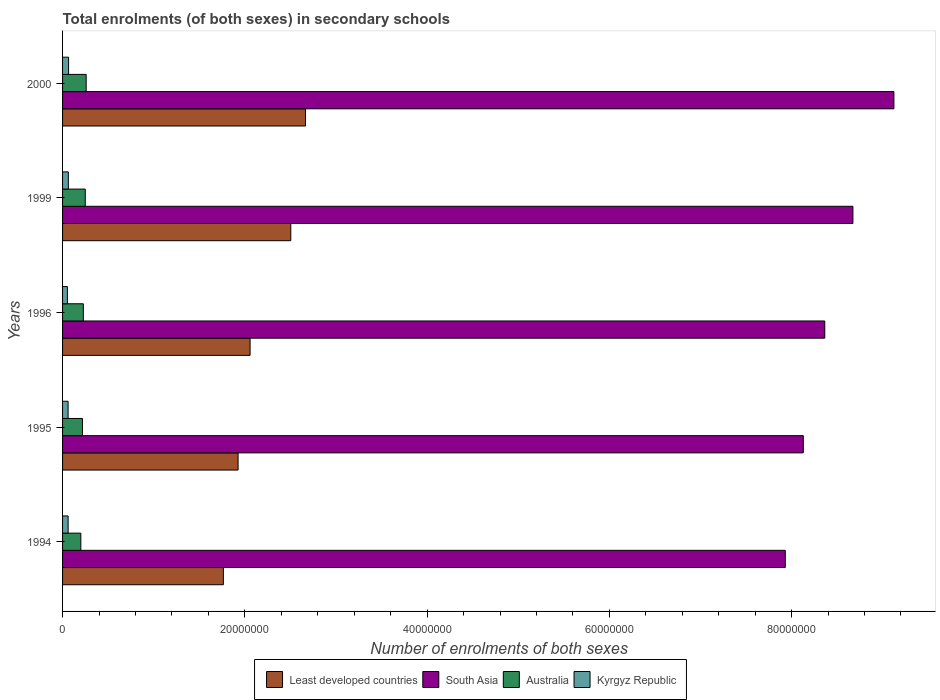How many different coloured bars are there?
Provide a succinct answer. 4. How many groups of bars are there?
Your response must be concise. 5. Are the number of bars per tick equal to the number of legend labels?
Your response must be concise. Yes. What is the number of enrolments in secondary schools in South Asia in 1999?
Your response must be concise. 8.67e+07. Across all years, what is the maximum number of enrolments in secondary schools in Least developed countries?
Offer a very short reply. 2.67e+07. Across all years, what is the minimum number of enrolments in secondary schools in Australia?
Offer a very short reply. 2.00e+06. In which year was the number of enrolments in secondary schools in South Asia maximum?
Make the answer very short. 2000. In which year was the number of enrolments in secondary schools in Kyrgyz Republic minimum?
Give a very brief answer. 1996. What is the total number of enrolments in secondary schools in Least developed countries in the graph?
Your answer should be very brief. 1.09e+08. What is the difference between the number of enrolments in secondary schools in Least developed countries in 1995 and that in 1999?
Keep it short and to the point. -5.78e+06. What is the difference between the number of enrolments in secondary schools in Australia in 1996 and the number of enrolments in secondary schools in Least developed countries in 1999?
Keep it short and to the point. -2.28e+07. What is the average number of enrolments in secondary schools in Least developed countries per year?
Provide a short and direct response. 2.18e+07. In the year 1995, what is the difference between the number of enrolments in secondary schools in Kyrgyz Republic and number of enrolments in secondary schools in South Asia?
Keep it short and to the point. -8.07e+07. What is the ratio of the number of enrolments in secondary schools in Australia in 1994 to that in 1999?
Ensure brevity in your answer.  0.8. Is the difference between the number of enrolments in secondary schools in Kyrgyz Republic in 1996 and 1999 greater than the difference between the number of enrolments in secondary schools in South Asia in 1996 and 1999?
Give a very brief answer. Yes. What is the difference between the highest and the second highest number of enrolments in secondary schools in Kyrgyz Republic?
Give a very brief answer. 2.61e+04. What is the difference between the highest and the lowest number of enrolments in secondary schools in Australia?
Your answer should be compact. 5.86e+05. What does the 1st bar from the top in 2000 represents?
Give a very brief answer. Kyrgyz Republic. What does the 4th bar from the bottom in 1999 represents?
Your answer should be very brief. Kyrgyz Republic. How many bars are there?
Your response must be concise. 20. How many years are there in the graph?
Your response must be concise. 5. Are the values on the major ticks of X-axis written in scientific E-notation?
Offer a terse response. No. Where does the legend appear in the graph?
Your answer should be compact. Bottom center. How many legend labels are there?
Make the answer very short. 4. How are the legend labels stacked?
Make the answer very short. Horizontal. What is the title of the graph?
Provide a succinct answer. Total enrolments (of both sexes) in secondary schools. What is the label or title of the X-axis?
Give a very brief answer. Number of enrolments of both sexes. What is the label or title of the Y-axis?
Your answer should be very brief. Years. What is the Number of enrolments of both sexes in Least developed countries in 1994?
Offer a terse response. 1.76e+07. What is the Number of enrolments of both sexes of South Asia in 1994?
Keep it short and to the point. 7.93e+07. What is the Number of enrolments of both sexes of Australia in 1994?
Provide a short and direct response. 2.00e+06. What is the Number of enrolments of both sexes in Kyrgyz Republic in 1994?
Your response must be concise. 6.10e+05. What is the Number of enrolments of both sexes of Least developed countries in 1995?
Make the answer very short. 1.93e+07. What is the Number of enrolments of both sexes of South Asia in 1995?
Offer a terse response. 8.13e+07. What is the Number of enrolments of both sexes of Australia in 1995?
Offer a very short reply. 2.18e+06. What is the Number of enrolments of both sexes in Kyrgyz Republic in 1995?
Keep it short and to the point. 6.06e+05. What is the Number of enrolments of both sexes in Least developed countries in 1996?
Your answer should be very brief. 2.06e+07. What is the Number of enrolments of both sexes in South Asia in 1996?
Ensure brevity in your answer.  8.36e+07. What is the Number of enrolments of both sexes of Australia in 1996?
Your answer should be compact. 2.28e+06. What is the Number of enrolments of both sexes of Kyrgyz Republic in 1996?
Give a very brief answer. 5.31e+05. What is the Number of enrolments of both sexes of Least developed countries in 1999?
Give a very brief answer. 2.50e+07. What is the Number of enrolments of both sexes of South Asia in 1999?
Ensure brevity in your answer.  8.67e+07. What is the Number of enrolments of both sexes in Australia in 1999?
Ensure brevity in your answer.  2.49e+06. What is the Number of enrolments of both sexes in Kyrgyz Republic in 1999?
Ensure brevity in your answer.  6.33e+05. What is the Number of enrolments of both sexes of Least developed countries in 2000?
Offer a very short reply. 2.67e+07. What is the Number of enrolments of both sexes of South Asia in 2000?
Your answer should be compact. 9.12e+07. What is the Number of enrolments of both sexes of Australia in 2000?
Offer a very short reply. 2.59e+06. What is the Number of enrolments of both sexes in Kyrgyz Republic in 2000?
Your response must be concise. 6.59e+05. Across all years, what is the maximum Number of enrolments of both sexes of Least developed countries?
Provide a short and direct response. 2.67e+07. Across all years, what is the maximum Number of enrolments of both sexes in South Asia?
Your response must be concise. 9.12e+07. Across all years, what is the maximum Number of enrolments of both sexes in Australia?
Make the answer very short. 2.59e+06. Across all years, what is the maximum Number of enrolments of both sexes of Kyrgyz Republic?
Give a very brief answer. 6.59e+05. Across all years, what is the minimum Number of enrolments of both sexes in Least developed countries?
Make the answer very short. 1.76e+07. Across all years, what is the minimum Number of enrolments of both sexes of South Asia?
Make the answer very short. 7.93e+07. Across all years, what is the minimum Number of enrolments of both sexes in Australia?
Offer a terse response. 2.00e+06. Across all years, what is the minimum Number of enrolments of both sexes of Kyrgyz Republic?
Your response must be concise. 5.31e+05. What is the total Number of enrolments of both sexes of Least developed countries in the graph?
Ensure brevity in your answer.  1.09e+08. What is the total Number of enrolments of both sexes of South Asia in the graph?
Keep it short and to the point. 4.22e+08. What is the total Number of enrolments of both sexes in Australia in the graph?
Give a very brief answer. 1.15e+07. What is the total Number of enrolments of both sexes of Kyrgyz Republic in the graph?
Keep it short and to the point. 3.04e+06. What is the difference between the Number of enrolments of both sexes of Least developed countries in 1994 and that in 1995?
Make the answer very short. -1.61e+06. What is the difference between the Number of enrolments of both sexes in South Asia in 1994 and that in 1995?
Your response must be concise. -1.98e+06. What is the difference between the Number of enrolments of both sexes of Australia in 1994 and that in 1995?
Ensure brevity in your answer.  -1.79e+05. What is the difference between the Number of enrolments of both sexes of Kyrgyz Republic in 1994 and that in 1995?
Provide a succinct answer. 3479. What is the difference between the Number of enrolments of both sexes of Least developed countries in 1994 and that in 1996?
Keep it short and to the point. -2.93e+06. What is the difference between the Number of enrolments of both sexes in South Asia in 1994 and that in 1996?
Your response must be concise. -4.34e+06. What is the difference between the Number of enrolments of both sexes of Australia in 1994 and that in 1996?
Provide a succinct answer. -2.77e+05. What is the difference between the Number of enrolments of both sexes in Kyrgyz Republic in 1994 and that in 1996?
Your response must be concise. 7.91e+04. What is the difference between the Number of enrolments of both sexes of Least developed countries in 1994 and that in 1999?
Your answer should be compact. -7.40e+06. What is the difference between the Number of enrolments of both sexes of South Asia in 1994 and that in 1999?
Offer a terse response. -7.42e+06. What is the difference between the Number of enrolments of both sexes in Australia in 1994 and that in 1999?
Provide a succinct answer. -4.88e+05. What is the difference between the Number of enrolments of both sexes of Kyrgyz Republic in 1994 and that in 1999?
Provide a succinct answer. -2.34e+04. What is the difference between the Number of enrolments of both sexes of Least developed countries in 1994 and that in 2000?
Ensure brevity in your answer.  -9.01e+06. What is the difference between the Number of enrolments of both sexes in South Asia in 1994 and that in 2000?
Offer a terse response. -1.19e+07. What is the difference between the Number of enrolments of both sexes of Australia in 1994 and that in 2000?
Keep it short and to the point. -5.86e+05. What is the difference between the Number of enrolments of both sexes of Kyrgyz Republic in 1994 and that in 2000?
Give a very brief answer. -4.95e+04. What is the difference between the Number of enrolments of both sexes in Least developed countries in 1995 and that in 1996?
Make the answer very short. -1.32e+06. What is the difference between the Number of enrolments of both sexes in South Asia in 1995 and that in 1996?
Your response must be concise. -2.36e+06. What is the difference between the Number of enrolments of both sexes in Australia in 1995 and that in 1996?
Provide a succinct answer. -9.82e+04. What is the difference between the Number of enrolments of both sexes of Kyrgyz Republic in 1995 and that in 1996?
Make the answer very short. 7.56e+04. What is the difference between the Number of enrolments of both sexes of Least developed countries in 1995 and that in 1999?
Provide a succinct answer. -5.78e+06. What is the difference between the Number of enrolments of both sexes of South Asia in 1995 and that in 1999?
Offer a terse response. -5.44e+06. What is the difference between the Number of enrolments of both sexes of Australia in 1995 and that in 1999?
Your response must be concise. -3.09e+05. What is the difference between the Number of enrolments of both sexes in Kyrgyz Republic in 1995 and that in 1999?
Ensure brevity in your answer.  -2.69e+04. What is the difference between the Number of enrolments of both sexes of Least developed countries in 1995 and that in 2000?
Provide a succinct answer. -7.40e+06. What is the difference between the Number of enrolments of both sexes in South Asia in 1995 and that in 2000?
Keep it short and to the point. -9.95e+06. What is the difference between the Number of enrolments of both sexes of Australia in 1995 and that in 2000?
Provide a short and direct response. -4.07e+05. What is the difference between the Number of enrolments of both sexes of Kyrgyz Republic in 1995 and that in 2000?
Ensure brevity in your answer.  -5.30e+04. What is the difference between the Number of enrolments of both sexes of Least developed countries in 1996 and that in 1999?
Keep it short and to the point. -4.47e+06. What is the difference between the Number of enrolments of both sexes of South Asia in 1996 and that in 1999?
Offer a terse response. -3.09e+06. What is the difference between the Number of enrolments of both sexes of Australia in 1996 and that in 1999?
Offer a very short reply. -2.11e+05. What is the difference between the Number of enrolments of both sexes in Kyrgyz Republic in 1996 and that in 1999?
Your answer should be very brief. -1.03e+05. What is the difference between the Number of enrolments of both sexes in Least developed countries in 1996 and that in 2000?
Offer a very short reply. -6.08e+06. What is the difference between the Number of enrolments of both sexes of South Asia in 1996 and that in 2000?
Give a very brief answer. -7.59e+06. What is the difference between the Number of enrolments of both sexes of Australia in 1996 and that in 2000?
Your response must be concise. -3.09e+05. What is the difference between the Number of enrolments of both sexes of Kyrgyz Republic in 1996 and that in 2000?
Your response must be concise. -1.29e+05. What is the difference between the Number of enrolments of both sexes of Least developed countries in 1999 and that in 2000?
Ensure brevity in your answer.  -1.62e+06. What is the difference between the Number of enrolments of both sexes in South Asia in 1999 and that in 2000?
Make the answer very short. -4.50e+06. What is the difference between the Number of enrolments of both sexes in Australia in 1999 and that in 2000?
Give a very brief answer. -9.81e+04. What is the difference between the Number of enrolments of both sexes of Kyrgyz Republic in 1999 and that in 2000?
Your answer should be compact. -2.61e+04. What is the difference between the Number of enrolments of both sexes of Least developed countries in 1994 and the Number of enrolments of both sexes of South Asia in 1995?
Ensure brevity in your answer.  -6.36e+07. What is the difference between the Number of enrolments of both sexes of Least developed countries in 1994 and the Number of enrolments of both sexes of Australia in 1995?
Offer a very short reply. 1.55e+07. What is the difference between the Number of enrolments of both sexes in Least developed countries in 1994 and the Number of enrolments of both sexes in Kyrgyz Republic in 1995?
Offer a very short reply. 1.70e+07. What is the difference between the Number of enrolments of both sexes in South Asia in 1994 and the Number of enrolments of both sexes in Australia in 1995?
Your answer should be compact. 7.71e+07. What is the difference between the Number of enrolments of both sexes of South Asia in 1994 and the Number of enrolments of both sexes of Kyrgyz Republic in 1995?
Your answer should be very brief. 7.87e+07. What is the difference between the Number of enrolments of both sexes in Australia in 1994 and the Number of enrolments of both sexes in Kyrgyz Republic in 1995?
Give a very brief answer. 1.40e+06. What is the difference between the Number of enrolments of both sexes in Least developed countries in 1994 and the Number of enrolments of both sexes in South Asia in 1996?
Your response must be concise. -6.60e+07. What is the difference between the Number of enrolments of both sexes of Least developed countries in 1994 and the Number of enrolments of both sexes of Australia in 1996?
Keep it short and to the point. 1.54e+07. What is the difference between the Number of enrolments of both sexes of Least developed countries in 1994 and the Number of enrolments of both sexes of Kyrgyz Republic in 1996?
Offer a very short reply. 1.71e+07. What is the difference between the Number of enrolments of both sexes of South Asia in 1994 and the Number of enrolments of both sexes of Australia in 1996?
Keep it short and to the point. 7.70e+07. What is the difference between the Number of enrolments of both sexes in South Asia in 1994 and the Number of enrolments of both sexes in Kyrgyz Republic in 1996?
Offer a terse response. 7.88e+07. What is the difference between the Number of enrolments of both sexes of Australia in 1994 and the Number of enrolments of both sexes of Kyrgyz Republic in 1996?
Offer a terse response. 1.47e+06. What is the difference between the Number of enrolments of both sexes of Least developed countries in 1994 and the Number of enrolments of both sexes of South Asia in 1999?
Your answer should be very brief. -6.91e+07. What is the difference between the Number of enrolments of both sexes in Least developed countries in 1994 and the Number of enrolments of both sexes in Australia in 1999?
Keep it short and to the point. 1.52e+07. What is the difference between the Number of enrolments of both sexes of Least developed countries in 1994 and the Number of enrolments of both sexes of Kyrgyz Republic in 1999?
Provide a short and direct response. 1.70e+07. What is the difference between the Number of enrolments of both sexes in South Asia in 1994 and the Number of enrolments of both sexes in Australia in 1999?
Your response must be concise. 7.68e+07. What is the difference between the Number of enrolments of both sexes in South Asia in 1994 and the Number of enrolments of both sexes in Kyrgyz Republic in 1999?
Your response must be concise. 7.87e+07. What is the difference between the Number of enrolments of both sexes of Australia in 1994 and the Number of enrolments of both sexes of Kyrgyz Republic in 1999?
Provide a short and direct response. 1.37e+06. What is the difference between the Number of enrolments of both sexes in Least developed countries in 1994 and the Number of enrolments of both sexes in South Asia in 2000?
Your answer should be compact. -7.36e+07. What is the difference between the Number of enrolments of both sexes of Least developed countries in 1994 and the Number of enrolments of both sexes of Australia in 2000?
Give a very brief answer. 1.51e+07. What is the difference between the Number of enrolments of both sexes of Least developed countries in 1994 and the Number of enrolments of both sexes of Kyrgyz Republic in 2000?
Make the answer very short. 1.70e+07. What is the difference between the Number of enrolments of both sexes in South Asia in 1994 and the Number of enrolments of both sexes in Australia in 2000?
Offer a terse response. 7.67e+07. What is the difference between the Number of enrolments of both sexes of South Asia in 1994 and the Number of enrolments of both sexes of Kyrgyz Republic in 2000?
Offer a very short reply. 7.86e+07. What is the difference between the Number of enrolments of both sexes in Australia in 1994 and the Number of enrolments of both sexes in Kyrgyz Republic in 2000?
Provide a succinct answer. 1.34e+06. What is the difference between the Number of enrolments of both sexes of Least developed countries in 1995 and the Number of enrolments of both sexes of South Asia in 1996?
Give a very brief answer. -6.44e+07. What is the difference between the Number of enrolments of both sexes of Least developed countries in 1995 and the Number of enrolments of both sexes of Australia in 1996?
Make the answer very short. 1.70e+07. What is the difference between the Number of enrolments of both sexes of Least developed countries in 1995 and the Number of enrolments of both sexes of Kyrgyz Republic in 1996?
Offer a very short reply. 1.87e+07. What is the difference between the Number of enrolments of both sexes of South Asia in 1995 and the Number of enrolments of both sexes of Australia in 1996?
Provide a short and direct response. 7.90e+07. What is the difference between the Number of enrolments of both sexes of South Asia in 1995 and the Number of enrolments of both sexes of Kyrgyz Republic in 1996?
Your answer should be very brief. 8.08e+07. What is the difference between the Number of enrolments of both sexes in Australia in 1995 and the Number of enrolments of both sexes in Kyrgyz Republic in 1996?
Your answer should be very brief. 1.65e+06. What is the difference between the Number of enrolments of both sexes of Least developed countries in 1995 and the Number of enrolments of both sexes of South Asia in 1999?
Ensure brevity in your answer.  -6.75e+07. What is the difference between the Number of enrolments of both sexes in Least developed countries in 1995 and the Number of enrolments of both sexes in Australia in 1999?
Ensure brevity in your answer.  1.68e+07. What is the difference between the Number of enrolments of both sexes in Least developed countries in 1995 and the Number of enrolments of both sexes in Kyrgyz Republic in 1999?
Your answer should be very brief. 1.86e+07. What is the difference between the Number of enrolments of both sexes in South Asia in 1995 and the Number of enrolments of both sexes in Australia in 1999?
Provide a short and direct response. 7.88e+07. What is the difference between the Number of enrolments of both sexes in South Asia in 1995 and the Number of enrolments of both sexes in Kyrgyz Republic in 1999?
Offer a very short reply. 8.06e+07. What is the difference between the Number of enrolments of both sexes in Australia in 1995 and the Number of enrolments of both sexes in Kyrgyz Republic in 1999?
Make the answer very short. 1.55e+06. What is the difference between the Number of enrolments of both sexes of Least developed countries in 1995 and the Number of enrolments of both sexes of South Asia in 2000?
Keep it short and to the point. -7.20e+07. What is the difference between the Number of enrolments of both sexes in Least developed countries in 1995 and the Number of enrolments of both sexes in Australia in 2000?
Your answer should be compact. 1.67e+07. What is the difference between the Number of enrolments of both sexes in Least developed countries in 1995 and the Number of enrolments of both sexes in Kyrgyz Republic in 2000?
Offer a very short reply. 1.86e+07. What is the difference between the Number of enrolments of both sexes of South Asia in 1995 and the Number of enrolments of both sexes of Australia in 2000?
Offer a very short reply. 7.87e+07. What is the difference between the Number of enrolments of both sexes in South Asia in 1995 and the Number of enrolments of both sexes in Kyrgyz Republic in 2000?
Your response must be concise. 8.06e+07. What is the difference between the Number of enrolments of both sexes in Australia in 1995 and the Number of enrolments of both sexes in Kyrgyz Republic in 2000?
Ensure brevity in your answer.  1.52e+06. What is the difference between the Number of enrolments of both sexes of Least developed countries in 1996 and the Number of enrolments of both sexes of South Asia in 1999?
Make the answer very short. -6.61e+07. What is the difference between the Number of enrolments of both sexes of Least developed countries in 1996 and the Number of enrolments of both sexes of Australia in 1999?
Offer a very short reply. 1.81e+07. What is the difference between the Number of enrolments of both sexes in Least developed countries in 1996 and the Number of enrolments of both sexes in Kyrgyz Republic in 1999?
Offer a very short reply. 1.99e+07. What is the difference between the Number of enrolments of both sexes of South Asia in 1996 and the Number of enrolments of both sexes of Australia in 1999?
Provide a short and direct response. 8.11e+07. What is the difference between the Number of enrolments of both sexes in South Asia in 1996 and the Number of enrolments of both sexes in Kyrgyz Republic in 1999?
Offer a terse response. 8.30e+07. What is the difference between the Number of enrolments of both sexes of Australia in 1996 and the Number of enrolments of both sexes of Kyrgyz Republic in 1999?
Provide a short and direct response. 1.65e+06. What is the difference between the Number of enrolments of both sexes in Least developed countries in 1996 and the Number of enrolments of both sexes in South Asia in 2000?
Provide a succinct answer. -7.07e+07. What is the difference between the Number of enrolments of both sexes in Least developed countries in 1996 and the Number of enrolments of both sexes in Australia in 2000?
Give a very brief answer. 1.80e+07. What is the difference between the Number of enrolments of both sexes of Least developed countries in 1996 and the Number of enrolments of both sexes of Kyrgyz Republic in 2000?
Provide a short and direct response. 1.99e+07. What is the difference between the Number of enrolments of both sexes of South Asia in 1996 and the Number of enrolments of both sexes of Australia in 2000?
Your response must be concise. 8.11e+07. What is the difference between the Number of enrolments of both sexes in South Asia in 1996 and the Number of enrolments of both sexes in Kyrgyz Republic in 2000?
Make the answer very short. 8.30e+07. What is the difference between the Number of enrolments of both sexes of Australia in 1996 and the Number of enrolments of both sexes of Kyrgyz Republic in 2000?
Ensure brevity in your answer.  1.62e+06. What is the difference between the Number of enrolments of both sexes in Least developed countries in 1999 and the Number of enrolments of both sexes in South Asia in 2000?
Give a very brief answer. -6.62e+07. What is the difference between the Number of enrolments of both sexes in Least developed countries in 1999 and the Number of enrolments of both sexes in Australia in 2000?
Provide a succinct answer. 2.25e+07. What is the difference between the Number of enrolments of both sexes in Least developed countries in 1999 and the Number of enrolments of both sexes in Kyrgyz Republic in 2000?
Provide a succinct answer. 2.44e+07. What is the difference between the Number of enrolments of both sexes of South Asia in 1999 and the Number of enrolments of both sexes of Australia in 2000?
Your response must be concise. 8.41e+07. What is the difference between the Number of enrolments of both sexes in South Asia in 1999 and the Number of enrolments of both sexes in Kyrgyz Republic in 2000?
Ensure brevity in your answer.  8.61e+07. What is the difference between the Number of enrolments of both sexes in Australia in 1999 and the Number of enrolments of both sexes in Kyrgyz Republic in 2000?
Provide a succinct answer. 1.83e+06. What is the average Number of enrolments of both sexes of Least developed countries per year?
Keep it short and to the point. 2.18e+07. What is the average Number of enrolments of both sexes in South Asia per year?
Offer a very short reply. 8.44e+07. What is the average Number of enrolments of both sexes in Australia per year?
Your answer should be compact. 2.31e+06. What is the average Number of enrolments of both sexes of Kyrgyz Republic per year?
Make the answer very short. 6.08e+05. In the year 1994, what is the difference between the Number of enrolments of both sexes in Least developed countries and Number of enrolments of both sexes in South Asia?
Your response must be concise. -6.17e+07. In the year 1994, what is the difference between the Number of enrolments of both sexes of Least developed countries and Number of enrolments of both sexes of Australia?
Ensure brevity in your answer.  1.56e+07. In the year 1994, what is the difference between the Number of enrolments of both sexes in Least developed countries and Number of enrolments of both sexes in Kyrgyz Republic?
Ensure brevity in your answer.  1.70e+07. In the year 1994, what is the difference between the Number of enrolments of both sexes in South Asia and Number of enrolments of both sexes in Australia?
Your answer should be very brief. 7.73e+07. In the year 1994, what is the difference between the Number of enrolments of both sexes in South Asia and Number of enrolments of both sexes in Kyrgyz Republic?
Your answer should be compact. 7.87e+07. In the year 1994, what is the difference between the Number of enrolments of both sexes in Australia and Number of enrolments of both sexes in Kyrgyz Republic?
Give a very brief answer. 1.39e+06. In the year 1995, what is the difference between the Number of enrolments of both sexes of Least developed countries and Number of enrolments of both sexes of South Asia?
Make the answer very short. -6.20e+07. In the year 1995, what is the difference between the Number of enrolments of both sexes in Least developed countries and Number of enrolments of both sexes in Australia?
Your answer should be very brief. 1.71e+07. In the year 1995, what is the difference between the Number of enrolments of both sexes in Least developed countries and Number of enrolments of both sexes in Kyrgyz Republic?
Offer a terse response. 1.87e+07. In the year 1995, what is the difference between the Number of enrolments of both sexes of South Asia and Number of enrolments of both sexes of Australia?
Your response must be concise. 7.91e+07. In the year 1995, what is the difference between the Number of enrolments of both sexes in South Asia and Number of enrolments of both sexes in Kyrgyz Republic?
Provide a short and direct response. 8.07e+07. In the year 1995, what is the difference between the Number of enrolments of both sexes of Australia and Number of enrolments of both sexes of Kyrgyz Republic?
Ensure brevity in your answer.  1.58e+06. In the year 1996, what is the difference between the Number of enrolments of both sexes of Least developed countries and Number of enrolments of both sexes of South Asia?
Offer a terse response. -6.31e+07. In the year 1996, what is the difference between the Number of enrolments of both sexes in Least developed countries and Number of enrolments of both sexes in Australia?
Your response must be concise. 1.83e+07. In the year 1996, what is the difference between the Number of enrolments of both sexes in Least developed countries and Number of enrolments of both sexes in Kyrgyz Republic?
Provide a succinct answer. 2.00e+07. In the year 1996, what is the difference between the Number of enrolments of both sexes of South Asia and Number of enrolments of both sexes of Australia?
Offer a very short reply. 8.14e+07. In the year 1996, what is the difference between the Number of enrolments of both sexes in South Asia and Number of enrolments of both sexes in Kyrgyz Republic?
Keep it short and to the point. 8.31e+07. In the year 1996, what is the difference between the Number of enrolments of both sexes in Australia and Number of enrolments of both sexes in Kyrgyz Republic?
Give a very brief answer. 1.75e+06. In the year 1999, what is the difference between the Number of enrolments of both sexes in Least developed countries and Number of enrolments of both sexes in South Asia?
Your response must be concise. -6.17e+07. In the year 1999, what is the difference between the Number of enrolments of both sexes in Least developed countries and Number of enrolments of both sexes in Australia?
Give a very brief answer. 2.26e+07. In the year 1999, what is the difference between the Number of enrolments of both sexes in Least developed countries and Number of enrolments of both sexes in Kyrgyz Republic?
Ensure brevity in your answer.  2.44e+07. In the year 1999, what is the difference between the Number of enrolments of both sexes in South Asia and Number of enrolments of both sexes in Australia?
Provide a short and direct response. 8.42e+07. In the year 1999, what is the difference between the Number of enrolments of both sexes in South Asia and Number of enrolments of both sexes in Kyrgyz Republic?
Your response must be concise. 8.61e+07. In the year 1999, what is the difference between the Number of enrolments of both sexes in Australia and Number of enrolments of both sexes in Kyrgyz Republic?
Keep it short and to the point. 1.86e+06. In the year 2000, what is the difference between the Number of enrolments of both sexes in Least developed countries and Number of enrolments of both sexes in South Asia?
Your answer should be compact. -6.46e+07. In the year 2000, what is the difference between the Number of enrolments of both sexes in Least developed countries and Number of enrolments of both sexes in Australia?
Keep it short and to the point. 2.41e+07. In the year 2000, what is the difference between the Number of enrolments of both sexes in Least developed countries and Number of enrolments of both sexes in Kyrgyz Republic?
Provide a short and direct response. 2.60e+07. In the year 2000, what is the difference between the Number of enrolments of both sexes in South Asia and Number of enrolments of both sexes in Australia?
Offer a terse response. 8.86e+07. In the year 2000, what is the difference between the Number of enrolments of both sexes in South Asia and Number of enrolments of both sexes in Kyrgyz Republic?
Offer a terse response. 9.06e+07. In the year 2000, what is the difference between the Number of enrolments of both sexes in Australia and Number of enrolments of both sexes in Kyrgyz Republic?
Keep it short and to the point. 1.93e+06. What is the ratio of the Number of enrolments of both sexes in Least developed countries in 1994 to that in 1995?
Keep it short and to the point. 0.92. What is the ratio of the Number of enrolments of both sexes in South Asia in 1994 to that in 1995?
Your answer should be compact. 0.98. What is the ratio of the Number of enrolments of both sexes in Australia in 1994 to that in 1995?
Your response must be concise. 0.92. What is the ratio of the Number of enrolments of both sexes of Least developed countries in 1994 to that in 1996?
Provide a short and direct response. 0.86. What is the ratio of the Number of enrolments of both sexes of South Asia in 1994 to that in 1996?
Give a very brief answer. 0.95. What is the ratio of the Number of enrolments of both sexes in Australia in 1994 to that in 1996?
Offer a very short reply. 0.88. What is the ratio of the Number of enrolments of both sexes of Kyrgyz Republic in 1994 to that in 1996?
Your answer should be compact. 1.15. What is the ratio of the Number of enrolments of both sexes of Least developed countries in 1994 to that in 1999?
Offer a terse response. 0.7. What is the ratio of the Number of enrolments of both sexes in South Asia in 1994 to that in 1999?
Provide a succinct answer. 0.91. What is the ratio of the Number of enrolments of both sexes in Australia in 1994 to that in 1999?
Your answer should be very brief. 0.8. What is the ratio of the Number of enrolments of both sexes in Least developed countries in 1994 to that in 2000?
Your response must be concise. 0.66. What is the ratio of the Number of enrolments of both sexes in South Asia in 1994 to that in 2000?
Your answer should be compact. 0.87. What is the ratio of the Number of enrolments of both sexes of Australia in 1994 to that in 2000?
Provide a short and direct response. 0.77. What is the ratio of the Number of enrolments of both sexes of Kyrgyz Republic in 1994 to that in 2000?
Your answer should be compact. 0.92. What is the ratio of the Number of enrolments of both sexes in Least developed countries in 1995 to that in 1996?
Your answer should be compact. 0.94. What is the ratio of the Number of enrolments of both sexes of South Asia in 1995 to that in 1996?
Provide a succinct answer. 0.97. What is the ratio of the Number of enrolments of both sexes of Australia in 1995 to that in 1996?
Ensure brevity in your answer.  0.96. What is the ratio of the Number of enrolments of both sexes of Kyrgyz Republic in 1995 to that in 1996?
Your response must be concise. 1.14. What is the ratio of the Number of enrolments of both sexes of Least developed countries in 1995 to that in 1999?
Your answer should be very brief. 0.77. What is the ratio of the Number of enrolments of both sexes in South Asia in 1995 to that in 1999?
Provide a short and direct response. 0.94. What is the ratio of the Number of enrolments of both sexes of Australia in 1995 to that in 1999?
Make the answer very short. 0.88. What is the ratio of the Number of enrolments of both sexes in Kyrgyz Republic in 1995 to that in 1999?
Provide a succinct answer. 0.96. What is the ratio of the Number of enrolments of both sexes in Least developed countries in 1995 to that in 2000?
Ensure brevity in your answer.  0.72. What is the ratio of the Number of enrolments of both sexes in South Asia in 1995 to that in 2000?
Your response must be concise. 0.89. What is the ratio of the Number of enrolments of both sexes in Australia in 1995 to that in 2000?
Make the answer very short. 0.84. What is the ratio of the Number of enrolments of both sexes of Kyrgyz Republic in 1995 to that in 2000?
Your answer should be very brief. 0.92. What is the ratio of the Number of enrolments of both sexes of Least developed countries in 1996 to that in 1999?
Provide a succinct answer. 0.82. What is the ratio of the Number of enrolments of both sexes in South Asia in 1996 to that in 1999?
Provide a succinct answer. 0.96. What is the ratio of the Number of enrolments of both sexes in Australia in 1996 to that in 1999?
Your answer should be compact. 0.92. What is the ratio of the Number of enrolments of both sexes of Kyrgyz Republic in 1996 to that in 1999?
Your answer should be very brief. 0.84. What is the ratio of the Number of enrolments of both sexes of Least developed countries in 1996 to that in 2000?
Your response must be concise. 0.77. What is the ratio of the Number of enrolments of both sexes of South Asia in 1996 to that in 2000?
Offer a very short reply. 0.92. What is the ratio of the Number of enrolments of both sexes of Australia in 1996 to that in 2000?
Keep it short and to the point. 0.88. What is the ratio of the Number of enrolments of both sexes of Kyrgyz Republic in 1996 to that in 2000?
Your answer should be very brief. 0.81. What is the ratio of the Number of enrolments of both sexes in Least developed countries in 1999 to that in 2000?
Provide a short and direct response. 0.94. What is the ratio of the Number of enrolments of both sexes of South Asia in 1999 to that in 2000?
Make the answer very short. 0.95. What is the ratio of the Number of enrolments of both sexes of Australia in 1999 to that in 2000?
Provide a short and direct response. 0.96. What is the ratio of the Number of enrolments of both sexes of Kyrgyz Republic in 1999 to that in 2000?
Your answer should be very brief. 0.96. What is the difference between the highest and the second highest Number of enrolments of both sexes of Least developed countries?
Give a very brief answer. 1.62e+06. What is the difference between the highest and the second highest Number of enrolments of both sexes in South Asia?
Offer a very short reply. 4.50e+06. What is the difference between the highest and the second highest Number of enrolments of both sexes in Australia?
Your response must be concise. 9.81e+04. What is the difference between the highest and the second highest Number of enrolments of both sexes in Kyrgyz Republic?
Keep it short and to the point. 2.61e+04. What is the difference between the highest and the lowest Number of enrolments of both sexes in Least developed countries?
Offer a terse response. 9.01e+06. What is the difference between the highest and the lowest Number of enrolments of both sexes of South Asia?
Offer a terse response. 1.19e+07. What is the difference between the highest and the lowest Number of enrolments of both sexes in Australia?
Offer a terse response. 5.86e+05. What is the difference between the highest and the lowest Number of enrolments of both sexes of Kyrgyz Republic?
Ensure brevity in your answer.  1.29e+05. 